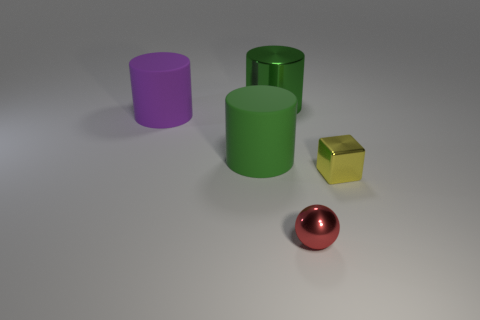Add 5 yellow blocks. How many objects exist? 10 Subtract all spheres. How many objects are left? 4 Subtract 0 red cylinders. How many objects are left? 5 Subtract all large yellow blocks. Subtract all green objects. How many objects are left? 3 Add 3 tiny yellow objects. How many tiny yellow objects are left? 4 Add 1 purple matte spheres. How many purple matte spheres exist? 1 